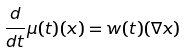Convert formula to latex. <formula><loc_0><loc_0><loc_500><loc_500>\frac { d } { d t } \mu ( t ) ( x ) = w ( t ) ( \nabla x )</formula> 